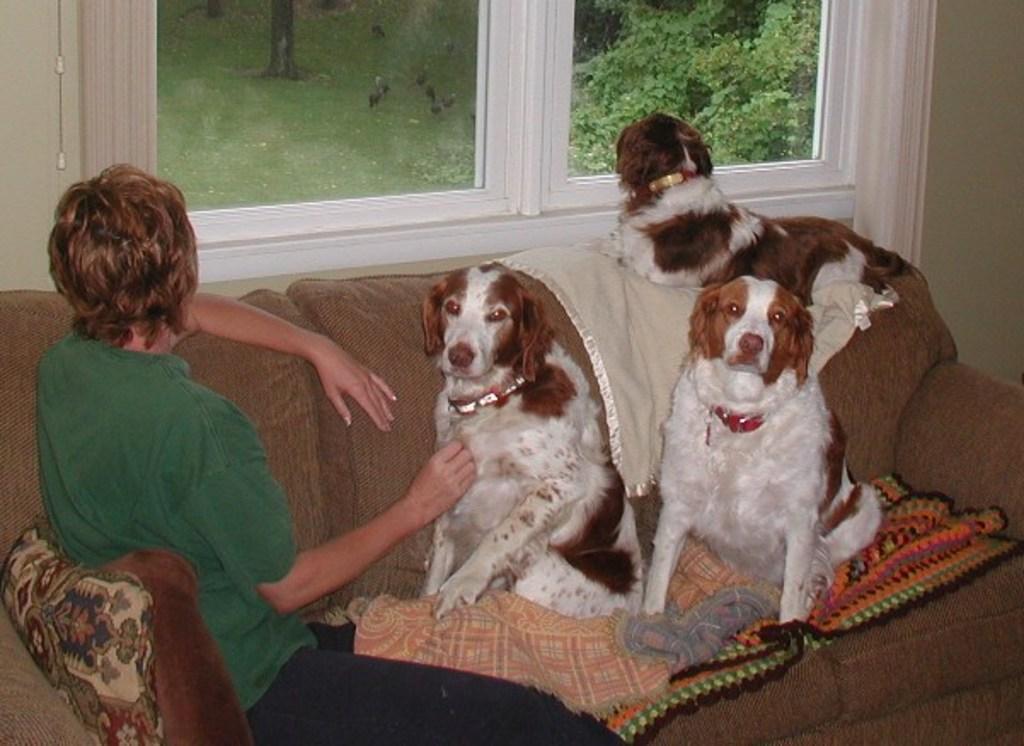Can you describe this image briefly? In this picture, the woman in the green shirt is sitting on the sofa. Beside her, we see three dogs on the sofa. Behind her, we see a wall and windows from which we can see trees and birds. This picture is clicked inside the room. 